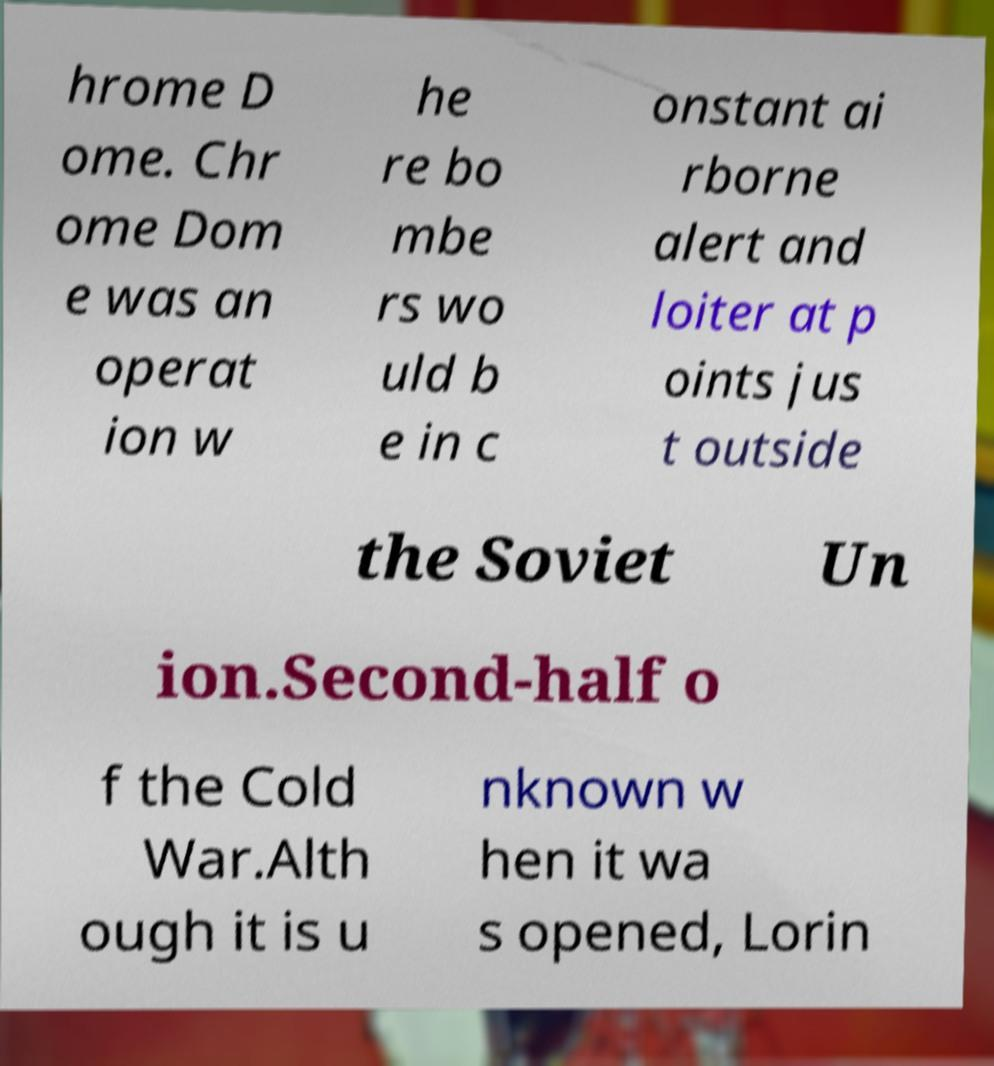For documentation purposes, I need the text within this image transcribed. Could you provide that? hrome D ome. Chr ome Dom e was an operat ion w he re bo mbe rs wo uld b e in c onstant ai rborne alert and loiter at p oints jus t outside the Soviet Un ion.Second-half o f the Cold War.Alth ough it is u nknown w hen it wa s opened, Lorin 